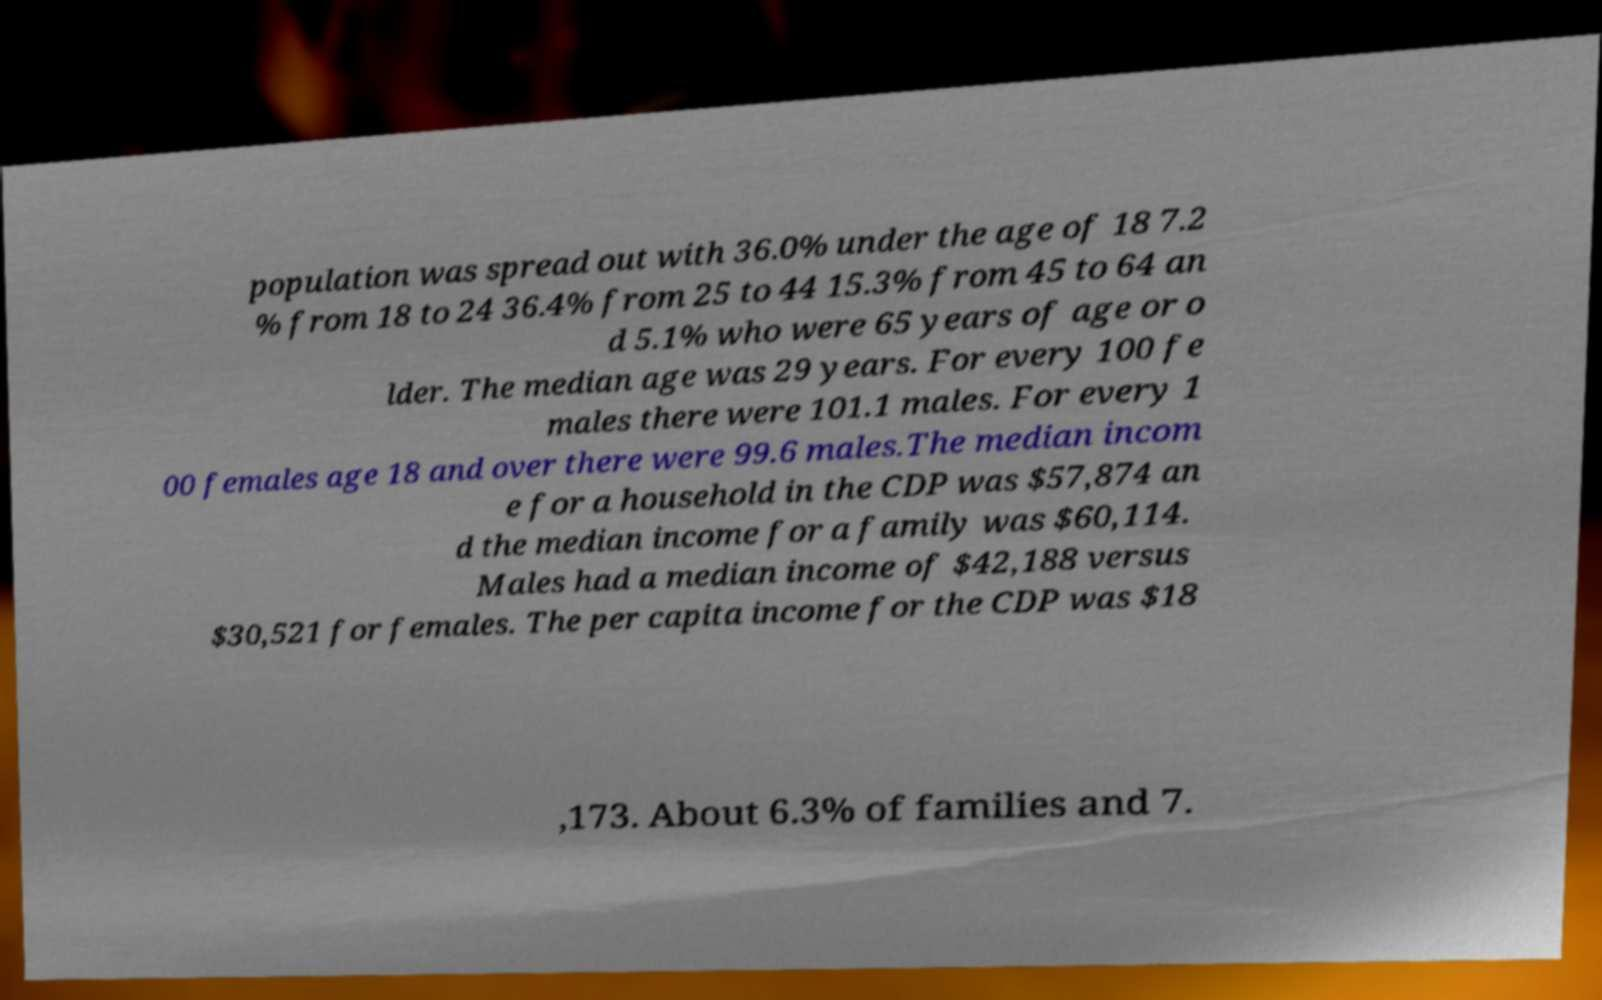Can you accurately transcribe the text from the provided image for me? population was spread out with 36.0% under the age of 18 7.2 % from 18 to 24 36.4% from 25 to 44 15.3% from 45 to 64 an d 5.1% who were 65 years of age or o lder. The median age was 29 years. For every 100 fe males there were 101.1 males. For every 1 00 females age 18 and over there were 99.6 males.The median incom e for a household in the CDP was $57,874 an d the median income for a family was $60,114. Males had a median income of $42,188 versus $30,521 for females. The per capita income for the CDP was $18 ,173. About 6.3% of families and 7. 